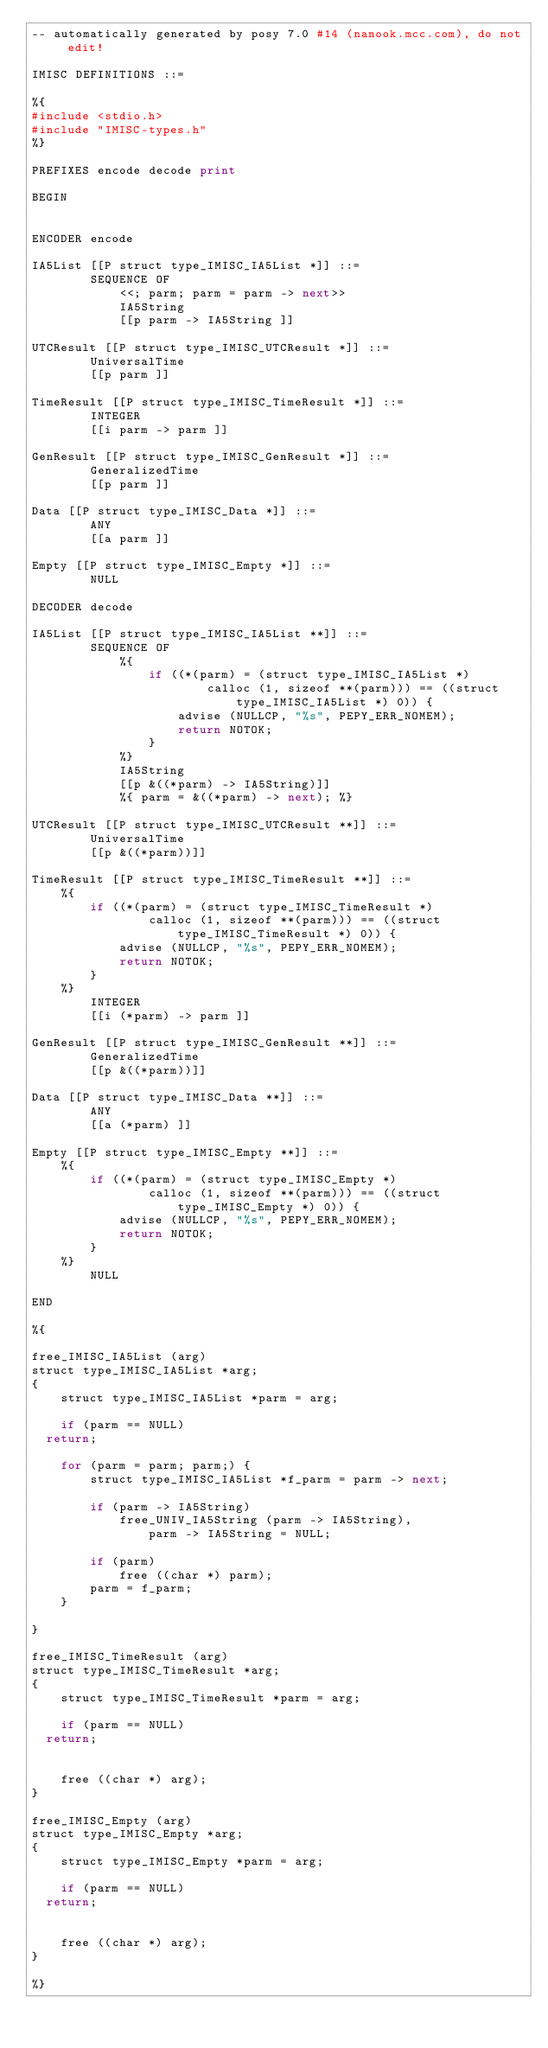Convert code to text. <code><loc_0><loc_0><loc_500><loc_500><_Python_>-- automatically generated by posy 7.0 #14 (nanook.mcc.com), do not edit!

IMISC DEFINITIONS ::=

%{
#include <stdio.h>
#include "IMISC-types.h"
%}

PREFIXES encode decode print

BEGIN


ENCODER encode

IA5List [[P struct type_IMISC_IA5List *]] ::=
        SEQUENCE OF
            <<; parm; parm = parm -> next>>
            IA5String
            [[p parm -> IA5String ]]

UTCResult [[P struct type_IMISC_UTCResult *]] ::=
        UniversalTime
        [[p parm ]]

TimeResult [[P struct type_IMISC_TimeResult *]] ::=
        INTEGER
        [[i parm -> parm ]]

GenResult [[P struct type_IMISC_GenResult *]] ::=
        GeneralizedTime
        [[p parm ]]

Data [[P struct type_IMISC_Data *]] ::=
        ANY
        [[a parm ]]

Empty [[P struct type_IMISC_Empty *]] ::=
        NULL

DECODER decode

IA5List [[P struct type_IMISC_IA5List **]] ::=
        SEQUENCE OF
            %{
                if ((*(parm) = (struct type_IMISC_IA5List *)
                        calloc (1, sizeof **(parm))) == ((struct type_IMISC_IA5List *) 0)) {
                    advise (NULLCP, "%s", PEPY_ERR_NOMEM);
                    return NOTOK;
                }
            %}
            IA5String
            [[p &((*parm) -> IA5String)]]
            %{ parm = &((*parm) -> next); %}

UTCResult [[P struct type_IMISC_UTCResult **]] ::=
        UniversalTime
        [[p &((*parm))]]

TimeResult [[P struct type_IMISC_TimeResult **]] ::=
    %{
        if ((*(parm) = (struct type_IMISC_TimeResult *)
                calloc (1, sizeof **(parm))) == ((struct type_IMISC_TimeResult *) 0)) {
            advise (NULLCP, "%s", PEPY_ERR_NOMEM);
            return NOTOK;
        }
    %}
        INTEGER
        [[i (*parm) -> parm ]]

GenResult [[P struct type_IMISC_GenResult **]] ::=
        GeneralizedTime
        [[p &((*parm))]]

Data [[P struct type_IMISC_Data **]] ::=
        ANY
        [[a (*parm) ]]

Empty [[P struct type_IMISC_Empty **]] ::=
    %{
        if ((*(parm) = (struct type_IMISC_Empty *)
                calloc (1, sizeof **(parm))) == ((struct type_IMISC_Empty *) 0)) {
            advise (NULLCP, "%s", PEPY_ERR_NOMEM);
            return NOTOK;
        }
    %}
        NULL

END

%{

free_IMISC_IA5List (arg)
struct type_IMISC_IA5List *arg;
{
    struct type_IMISC_IA5List *parm = arg;

    if (parm == NULL)
	return;

    for (parm = parm; parm;) {
        struct type_IMISC_IA5List *f_parm = parm -> next;

        if (parm -> IA5String)
            free_UNIV_IA5String (parm -> IA5String),
                parm -> IA5String = NULL;

        if (parm)
            free ((char *) parm);
        parm = f_parm;
    }

}

free_IMISC_TimeResult (arg)
struct type_IMISC_TimeResult *arg;
{
    struct type_IMISC_TimeResult *parm = arg;

    if (parm == NULL)
	return;


    free ((char *) arg);
}

free_IMISC_Empty (arg)
struct type_IMISC_Empty *arg;
{
    struct type_IMISC_Empty *parm = arg;

    if (parm == NULL)
	return;


    free ((char *) arg);
}

%}
</code> 